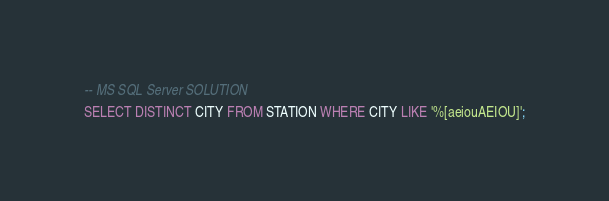<code> <loc_0><loc_0><loc_500><loc_500><_SQL_>
-- MS SQL Server SOLUTION

SELECT DISTINCT CITY FROM STATION WHERE CITY LIKE '%[aeiouAEIOU]';
</code> 